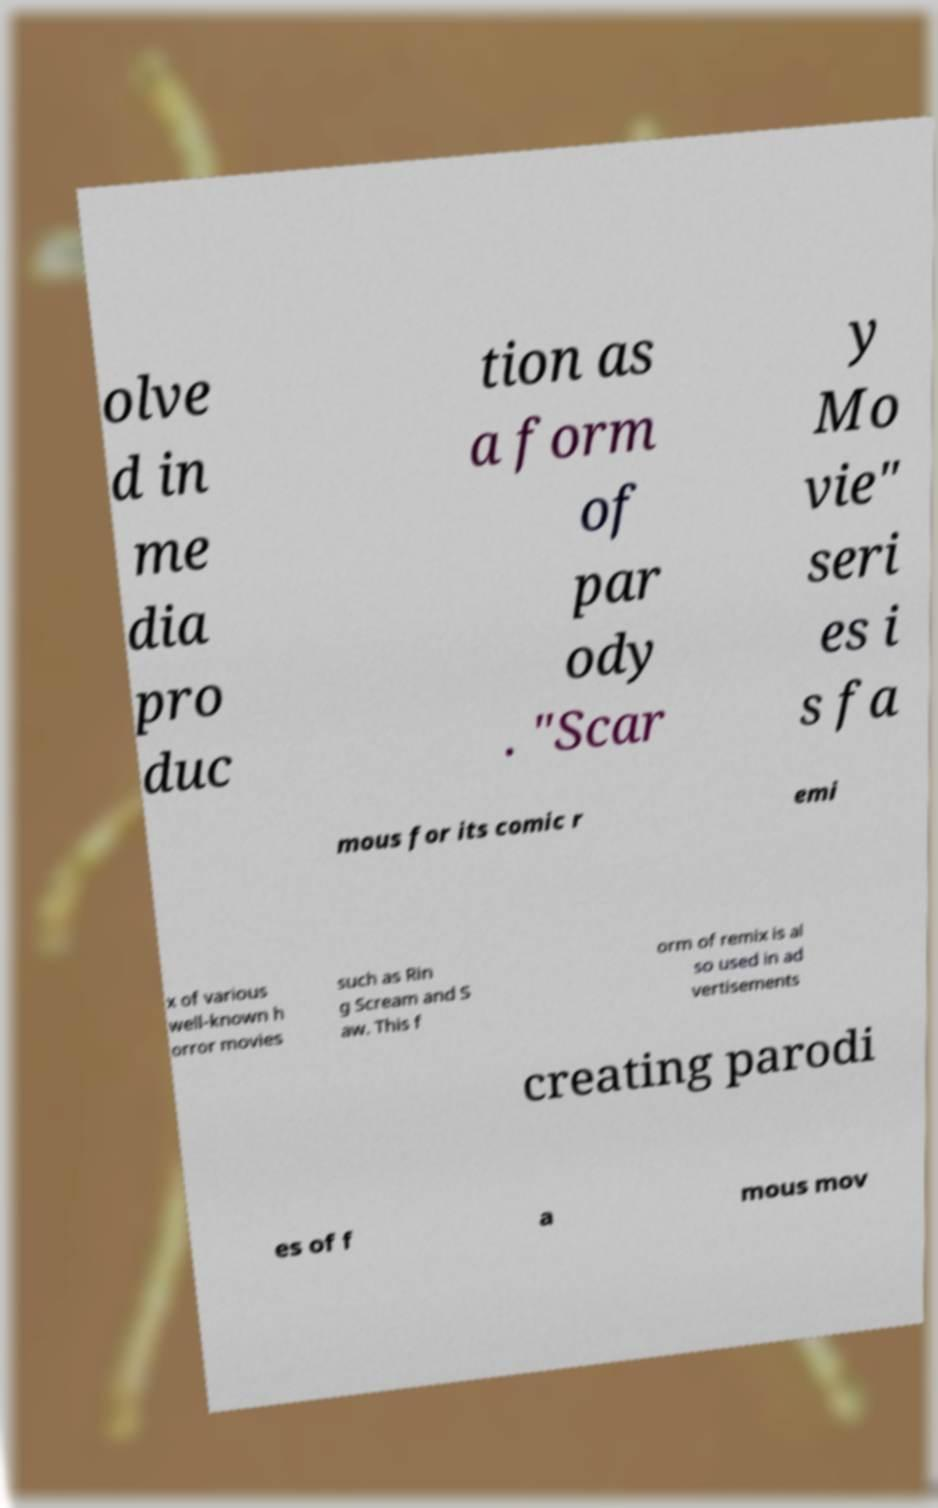For documentation purposes, I need the text within this image transcribed. Could you provide that? olve d in me dia pro duc tion as a form of par ody . "Scar y Mo vie" seri es i s fa mous for its comic r emi x of various well-known h orror movies such as Rin g Scream and S aw. This f orm of remix is al so used in ad vertisements creating parodi es of f a mous mov 